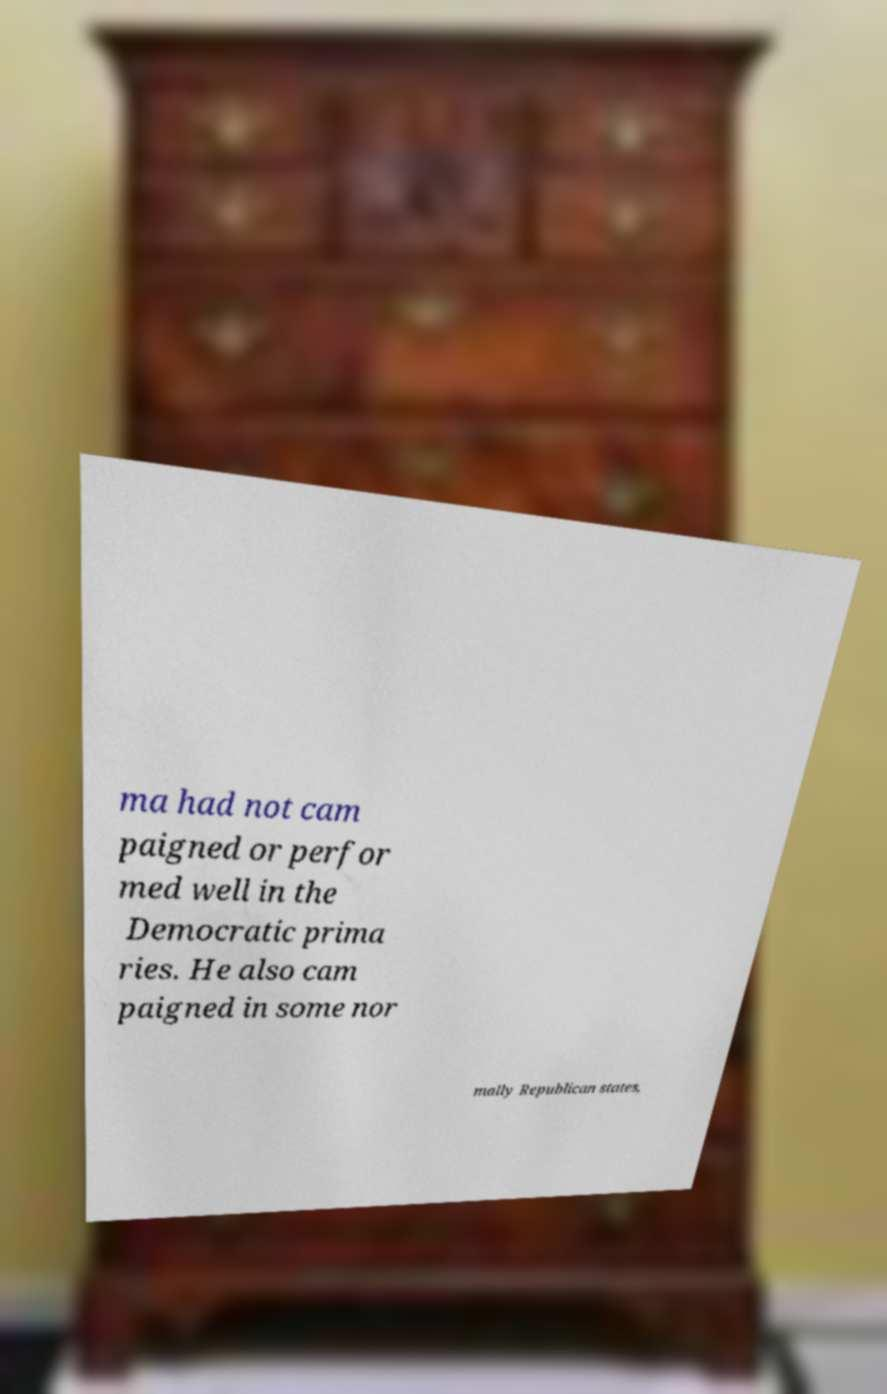What messages or text are displayed in this image? I need them in a readable, typed format. ma had not cam paigned or perfor med well in the Democratic prima ries. He also cam paigned in some nor mally Republican states, 